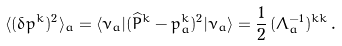<formula> <loc_0><loc_0><loc_500><loc_500>\langle ( \delta { p ^ { k } } ) ^ { 2 } \rangle _ { a } = \langle \nu _ { a } | ( \widehat { P } ^ { k } - p _ { a } ^ { k } ) ^ { 2 } | \nu _ { a } \rangle = \frac { 1 } { 2 } \, ( \Lambda _ { a } ^ { - 1 } ) ^ { k k } \, .</formula> 